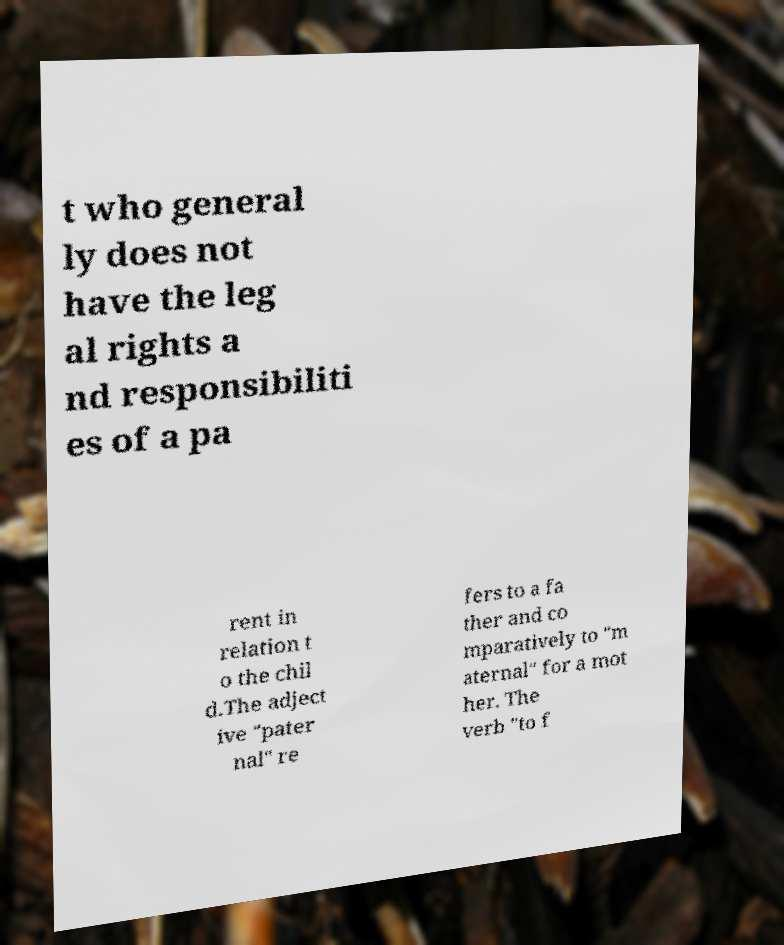Could you extract and type out the text from this image? t who general ly does not have the leg al rights a nd responsibiliti es of a pa rent in relation t o the chil d.The adject ive "pater nal" re fers to a fa ther and co mparatively to "m aternal" for a mot her. The verb "to f 